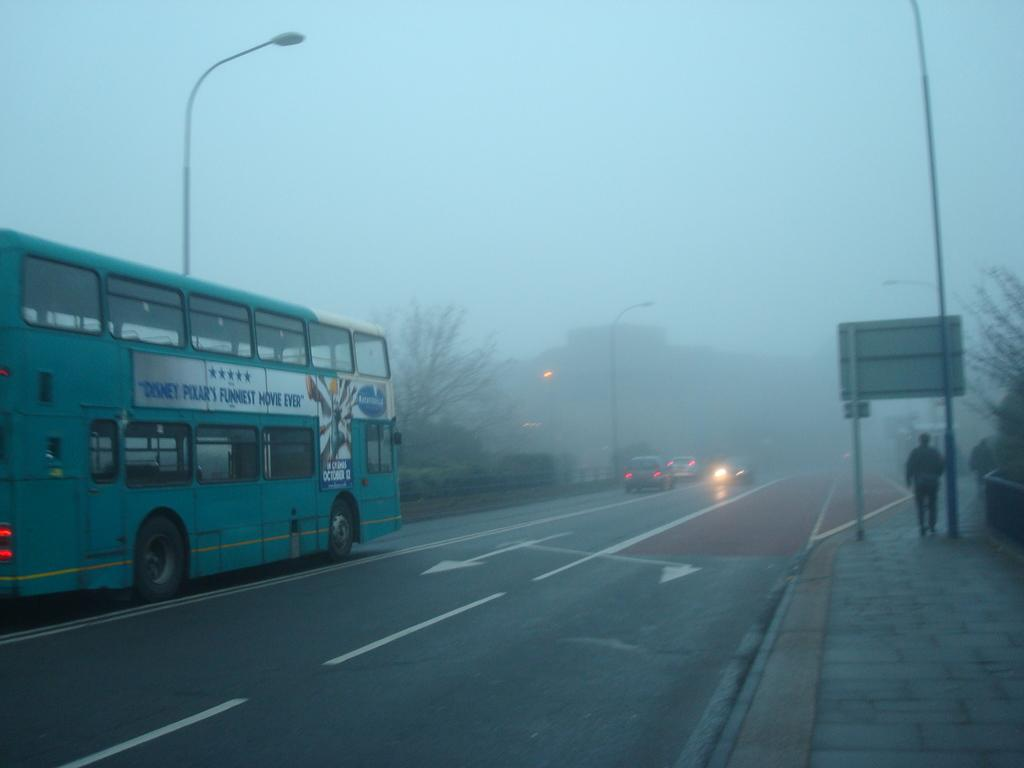What can be seen on the road in the image? There are vehicles on the road in the image. What is the board visible in the image used for? The purpose of the board in the image is not specified, but it could be a sign or advertisement. What structures are present along the road in the image? Light poles are present in the image. What type of vegetation is visible in the image? Trees are visible in the image. What feature of the vehicles can be seen in the image? Car headlights are present in the image. What type of building is visible in the image? There is a house in the image. What part of the natural environment is visible in the image? The sky is visible in the image. What type of curtain is hanging in the house in the image? There is no curtain visible in the house in the image. How does the development of the vehicles in the image affect the environment? The provided facts do not mention any information about the development of the vehicles or their impact on the environment. 